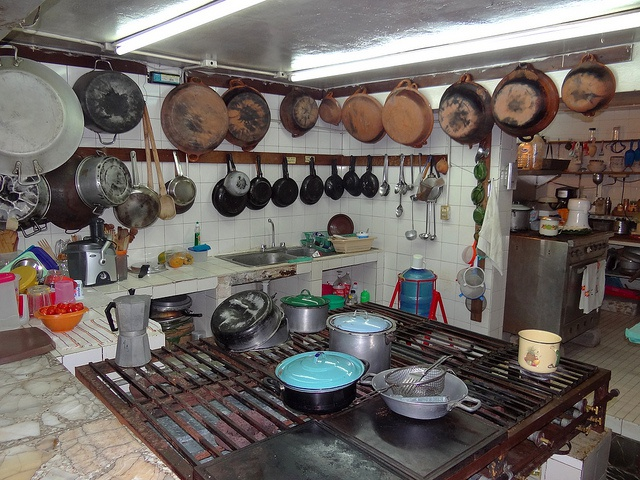Describe the objects in this image and their specific colors. I can see oven in gray, black, and darkgray tones, oven in gray and black tones, bowl in gray, black, teal, and lightblue tones, bowl in gray, darkgray, and black tones, and sink in gray, black, and darkgray tones in this image. 